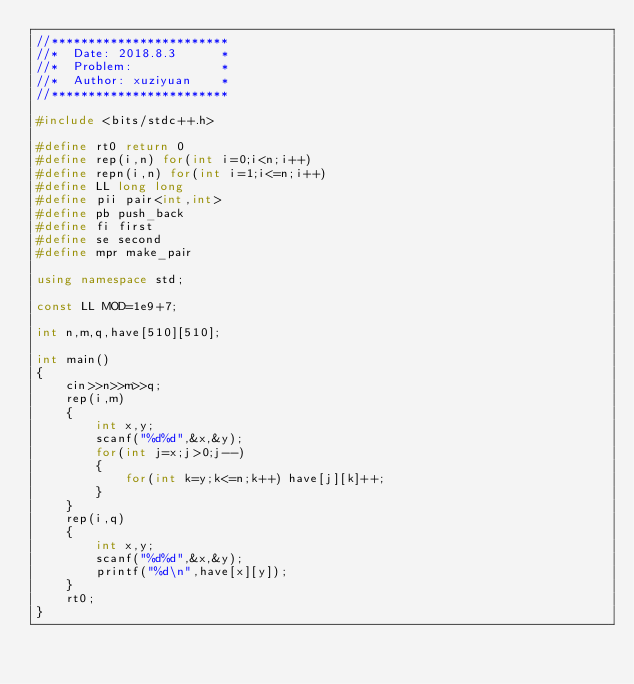Convert code to text. <code><loc_0><loc_0><loc_500><loc_500><_C++_>//************************
//*  Date: 2018.8.3      *
//*  Problem:            *
//*  Author: xuziyuan    * 
//************************

#include <bits/stdc++.h>

#define rt0 return 0
#define rep(i,n) for(int i=0;i<n;i++)
#define repn(i,n) for(int i=1;i<=n;i++)
#define LL long long
#define pii pair<int,int>
#define pb push_back
#define fi first
#define se second
#define mpr make_pair

using namespace std;

const LL MOD=1e9+7;

int n,m,q,have[510][510];

int main()
{
	cin>>n>>m>>q;
	rep(i,m)
	{
		int x,y;
		scanf("%d%d",&x,&y);
		for(int j=x;j>0;j--)
		{
			for(int k=y;k<=n;k++) have[j][k]++;
		}
	}
	rep(i,q)
	{
		int x,y;
		scanf("%d%d",&x,&y);
		printf("%d\n",have[x][y]);
	}
	rt0;
}</code> 